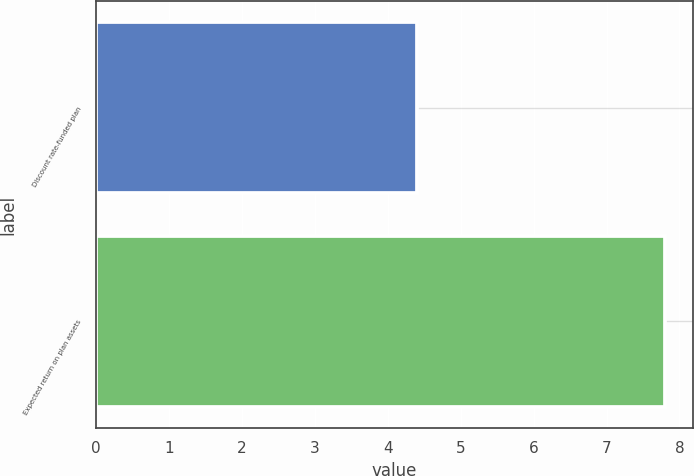<chart> <loc_0><loc_0><loc_500><loc_500><bar_chart><fcel>Discount rate-funded plan<fcel>Expected return on plan assets<nl><fcel>4.4<fcel>7.8<nl></chart> 